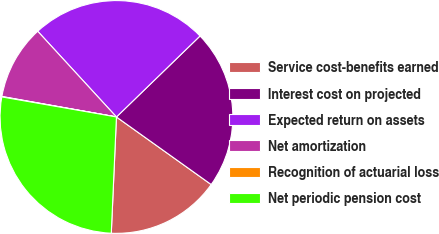Convert chart. <chart><loc_0><loc_0><loc_500><loc_500><pie_chart><fcel>Service cost-benefits earned<fcel>Interest cost on projected<fcel>Expected return on assets<fcel>Net amortization<fcel>Recognition of actuarial loss<fcel>Net periodic pension cost<nl><fcel>15.85%<fcel>22.11%<fcel>24.58%<fcel>10.36%<fcel>0.06%<fcel>27.05%<nl></chart> 